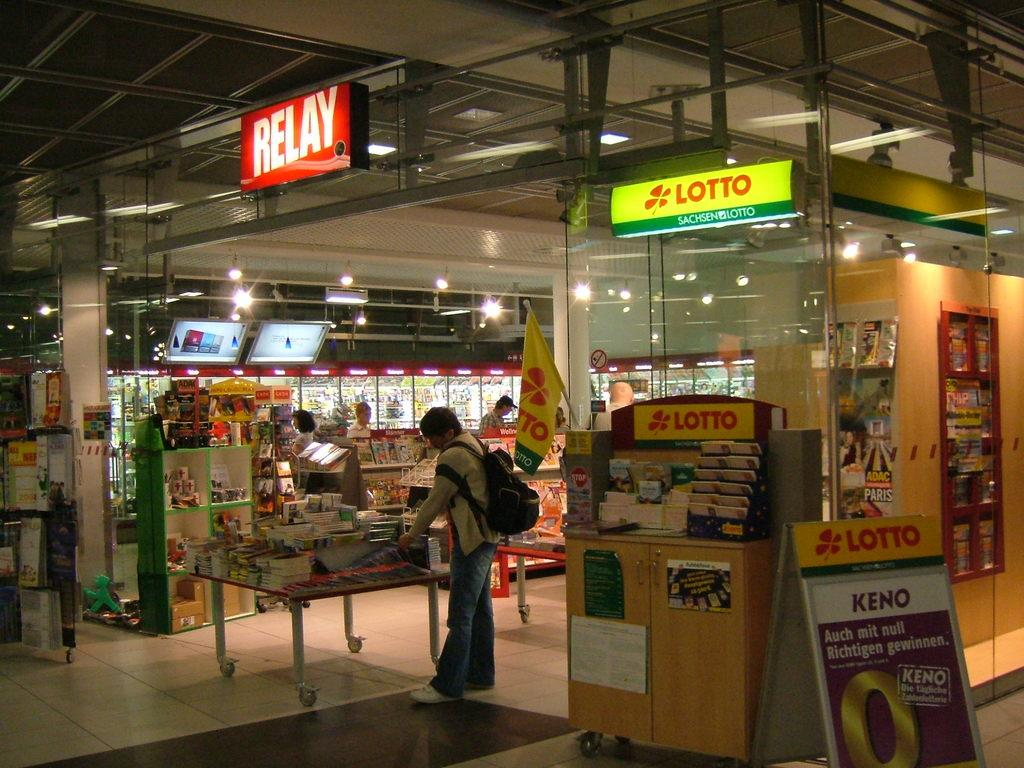<image>
Provide a brief description of the given image. A Sachsen lotto machine sits next to the Relay store. 